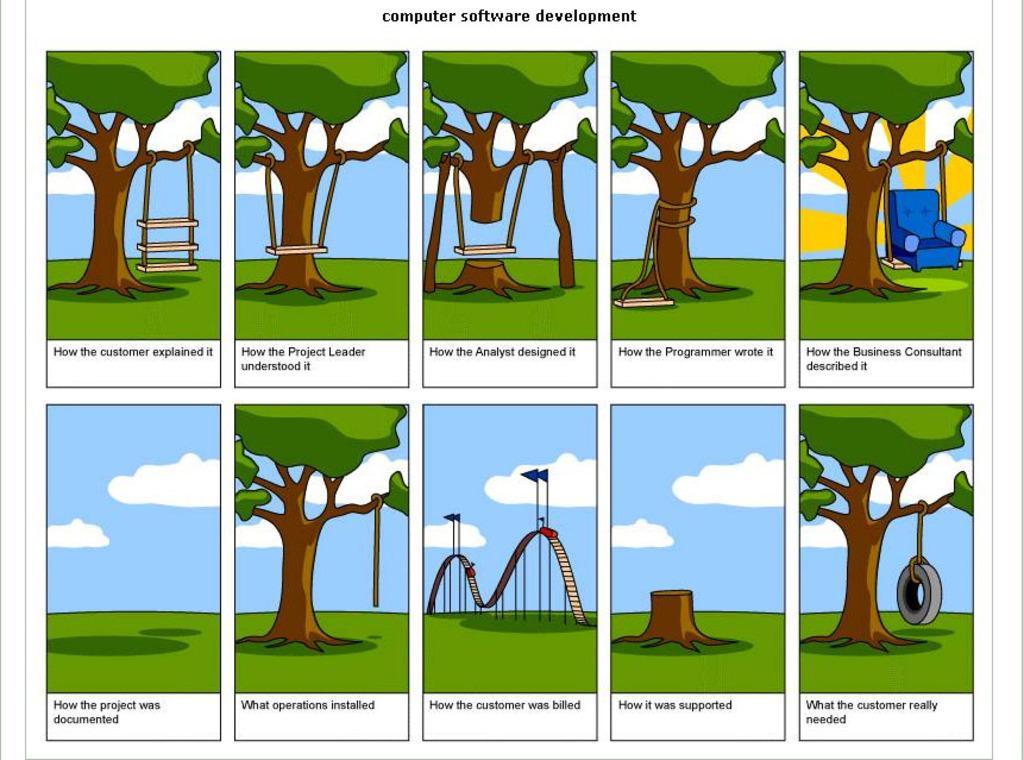How would you summarize this image in a sentence or two? In this picture we can see cartoon images, in these images there are trees, grass, the sky and clouds, we can also see some text, in the right bottom picture we can see a tyre, in this image we can see roller coaster and flags. 